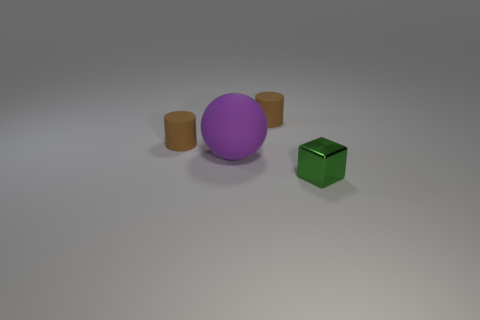Add 1 tiny purple rubber cylinders. How many objects exist? 5 Subtract 1 cylinders. How many cylinders are left? 1 Subtract all red balls. Subtract all brown cylinders. How many balls are left? 1 Subtract all green shiny things. Subtract all big green objects. How many objects are left? 3 Add 1 balls. How many balls are left? 2 Add 4 small rubber cylinders. How many small rubber cylinders exist? 6 Subtract 0 cyan spheres. How many objects are left? 4 Subtract all blocks. How many objects are left? 3 